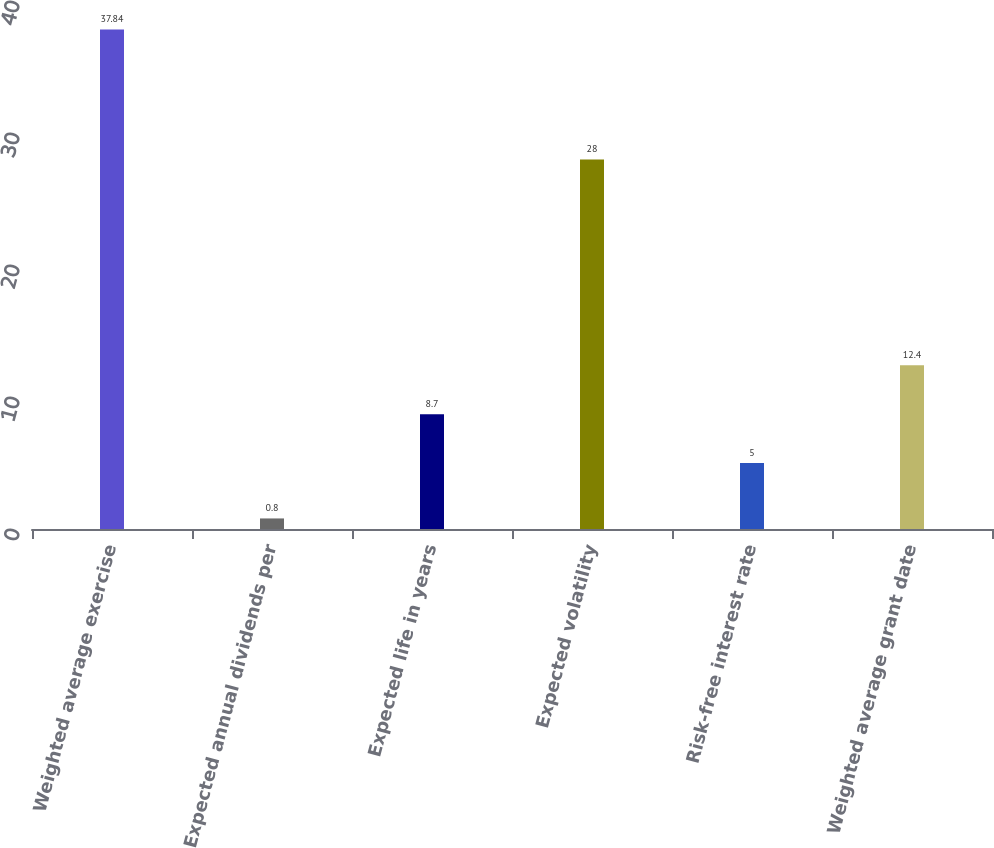Convert chart to OTSL. <chart><loc_0><loc_0><loc_500><loc_500><bar_chart><fcel>Weighted average exercise<fcel>Expected annual dividends per<fcel>Expected life in years<fcel>Expected volatility<fcel>Risk-free interest rate<fcel>Weighted average grant date<nl><fcel>37.84<fcel>0.8<fcel>8.7<fcel>28<fcel>5<fcel>12.4<nl></chart> 